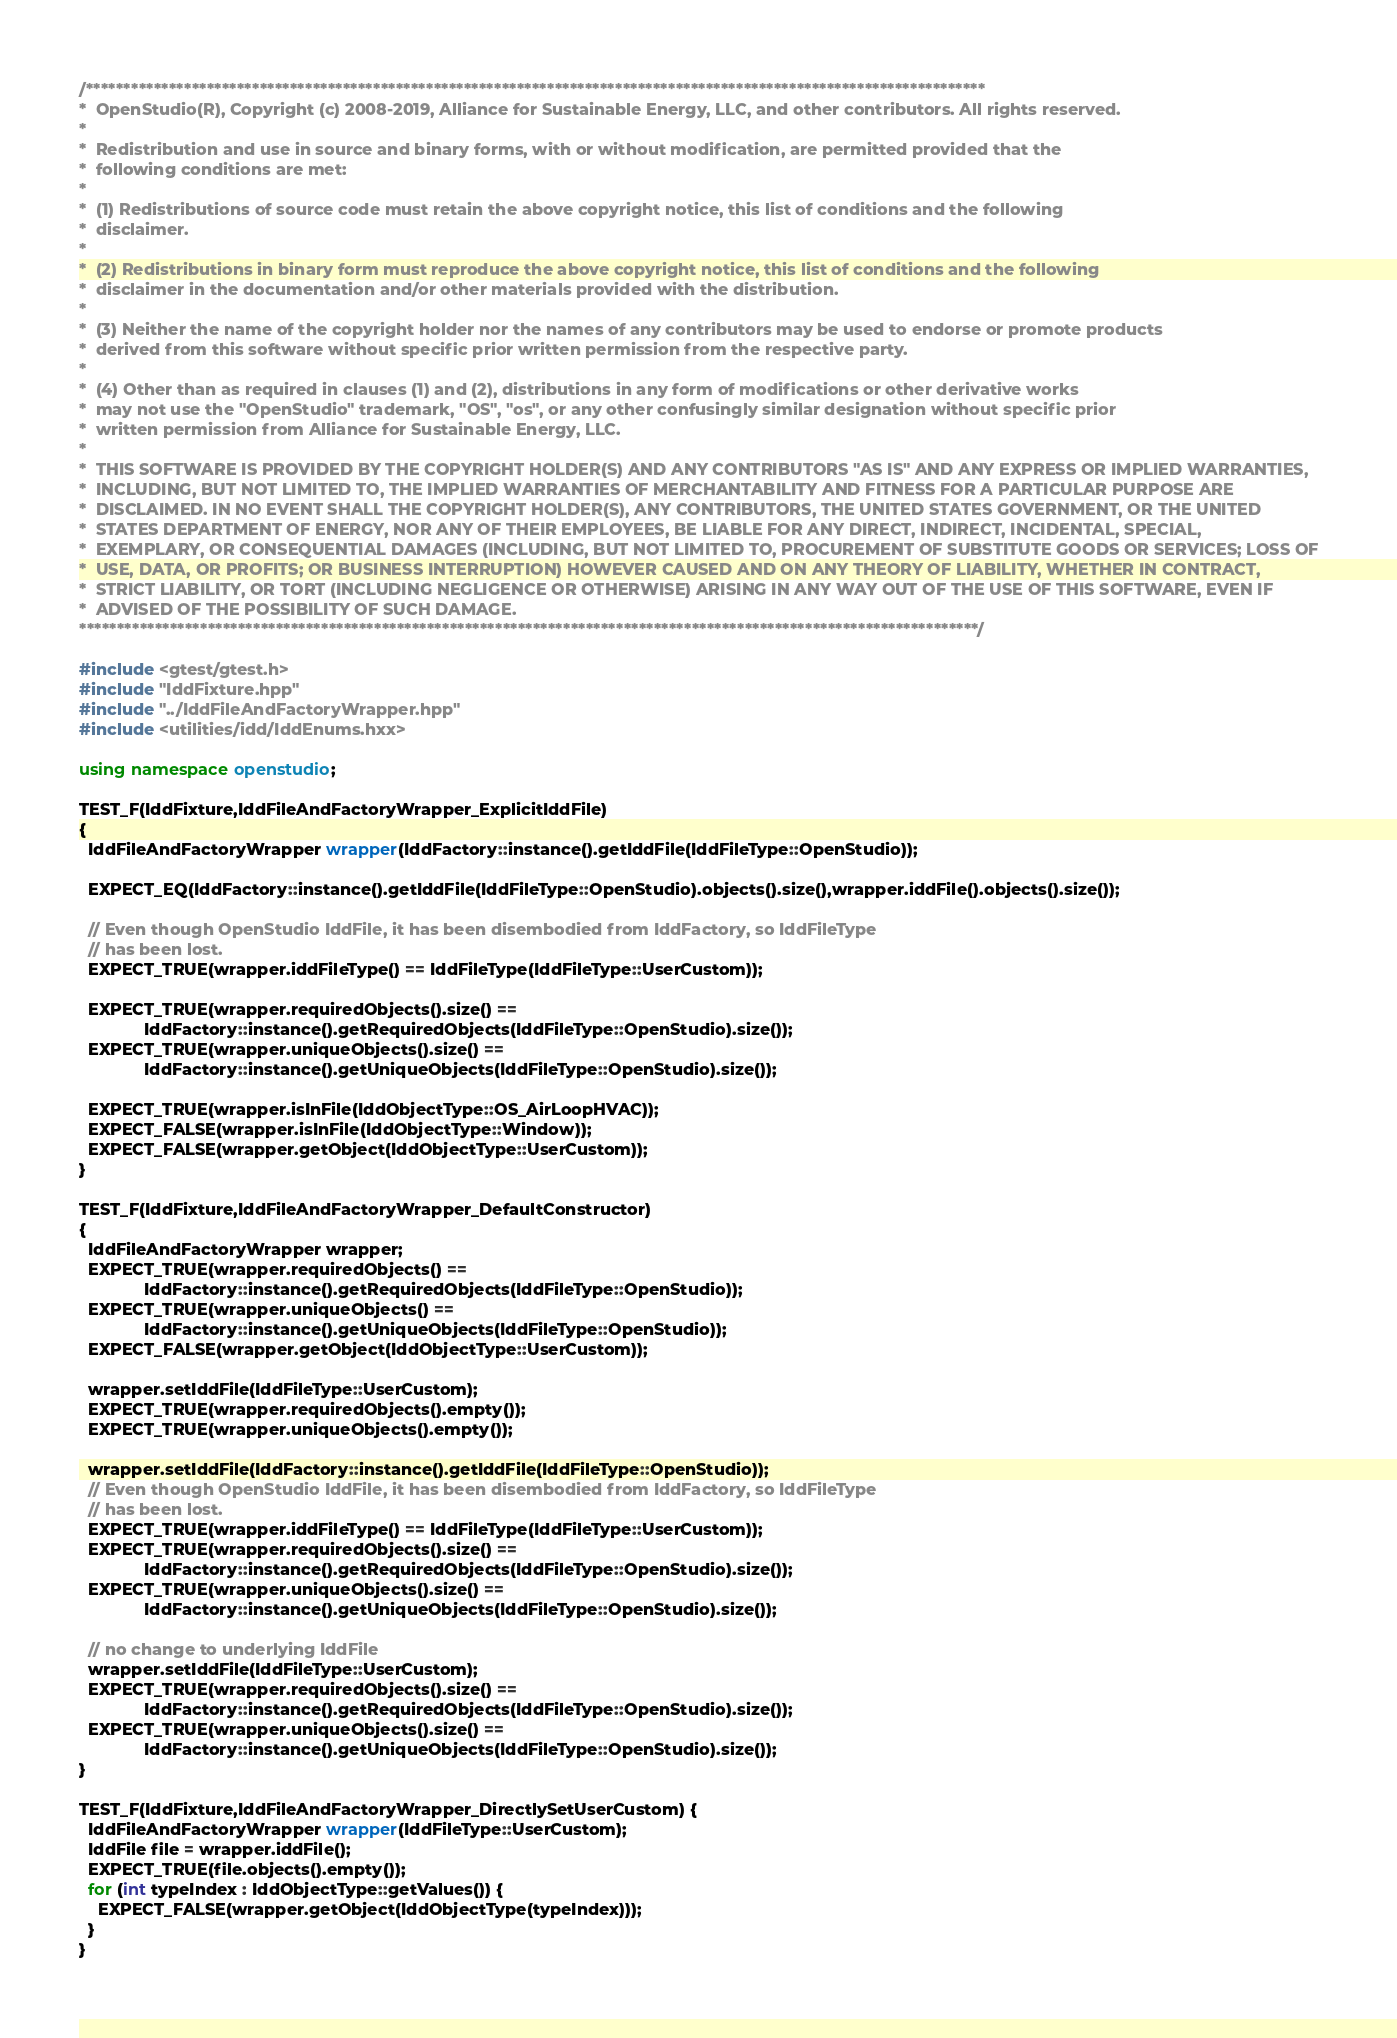<code> <loc_0><loc_0><loc_500><loc_500><_C++_>/***********************************************************************************************************************
*  OpenStudio(R), Copyright (c) 2008-2019, Alliance for Sustainable Energy, LLC, and other contributors. All rights reserved.
*
*  Redistribution and use in source and binary forms, with or without modification, are permitted provided that the
*  following conditions are met:
*
*  (1) Redistributions of source code must retain the above copyright notice, this list of conditions and the following
*  disclaimer.
*
*  (2) Redistributions in binary form must reproduce the above copyright notice, this list of conditions and the following
*  disclaimer in the documentation and/or other materials provided with the distribution.
*
*  (3) Neither the name of the copyright holder nor the names of any contributors may be used to endorse or promote products
*  derived from this software without specific prior written permission from the respective party.
*
*  (4) Other than as required in clauses (1) and (2), distributions in any form of modifications or other derivative works
*  may not use the "OpenStudio" trademark, "OS", "os", or any other confusingly similar designation without specific prior
*  written permission from Alliance for Sustainable Energy, LLC.
*
*  THIS SOFTWARE IS PROVIDED BY THE COPYRIGHT HOLDER(S) AND ANY CONTRIBUTORS "AS IS" AND ANY EXPRESS OR IMPLIED WARRANTIES,
*  INCLUDING, BUT NOT LIMITED TO, THE IMPLIED WARRANTIES OF MERCHANTABILITY AND FITNESS FOR A PARTICULAR PURPOSE ARE
*  DISCLAIMED. IN NO EVENT SHALL THE COPYRIGHT HOLDER(S), ANY CONTRIBUTORS, THE UNITED STATES GOVERNMENT, OR THE UNITED
*  STATES DEPARTMENT OF ENERGY, NOR ANY OF THEIR EMPLOYEES, BE LIABLE FOR ANY DIRECT, INDIRECT, INCIDENTAL, SPECIAL,
*  EXEMPLARY, OR CONSEQUENTIAL DAMAGES (INCLUDING, BUT NOT LIMITED TO, PROCUREMENT OF SUBSTITUTE GOODS OR SERVICES; LOSS OF
*  USE, DATA, OR PROFITS; OR BUSINESS INTERRUPTION) HOWEVER CAUSED AND ON ANY THEORY OF LIABILITY, WHETHER IN CONTRACT,
*  STRICT LIABILITY, OR TORT (INCLUDING NEGLIGENCE OR OTHERWISE) ARISING IN ANY WAY OUT OF THE USE OF THIS SOFTWARE, EVEN IF
*  ADVISED OF THE POSSIBILITY OF SUCH DAMAGE.
***********************************************************************************************************************/

#include <gtest/gtest.h>
#include "IddFixture.hpp"
#include "../IddFileAndFactoryWrapper.hpp"
#include <utilities/idd/IddEnums.hxx>

using namespace openstudio;

TEST_F(IddFixture,IddFileAndFactoryWrapper_ExplicitIddFile)
{
  IddFileAndFactoryWrapper wrapper(IddFactory::instance().getIddFile(IddFileType::OpenStudio));

  EXPECT_EQ(IddFactory::instance().getIddFile(IddFileType::OpenStudio).objects().size(),wrapper.iddFile().objects().size());

  // Even though OpenStudio IddFile, it has been disembodied from IddFactory, so IddFileType
  // has been lost.
  EXPECT_TRUE(wrapper.iddFileType() == IddFileType(IddFileType::UserCustom));

  EXPECT_TRUE(wrapper.requiredObjects().size() ==
              IddFactory::instance().getRequiredObjects(IddFileType::OpenStudio).size());
  EXPECT_TRUE(wrapper.uniqueObjects().size() ==
              IddFactory::instance().getUniqueObjects(IddFileType::OpenStudio).size());

  EXPECT_TRUE(wrapper.isInFile(IddObjectType::OS_AirLoopHVAC));
  EXPECT_FALSE(wrapper.isInFile(IddObjectType::Window));
  EXPECT_FALSE(wrapper.getObject(IddObjectType::UserCustom));
}

TEST_F(IddFixture,IddFileAndFactoryWrapper_DefaultConstructor)
{
  IddFileAndFactoryWrapper wrapper;
  EXPECT_TRUE(wrapper.requiredObjects() ==
              IddFactory::instance().getRequiredObjects(IddFileType::OpenStudio));
  EXPECT_TRUE(wrapper.uniqueObjects() ==
              IddFactory::instance().getUniqueObjects(IddFileType::OpenStudio));
  EXPECT_FALSE(wrapper.getObject(IddObjectType::UserCustom));

  wrapper.setIddFile(IddFileType::UserCustom);
  EXPECT_TRUE(wrapper.requiredObjects().empty());
  EXPECT_TRUE(wrapper.uniqueObjects().empty());

  wrapper.setIddFile(IddFactory::instance().getIddFile(IddFileType::OpenStudio));
  // Even though OpenStudio IddFile, it has been disembodied from IddFactory, so IddFileType
  // has been lost.
  EXPECT_TRUE(wrapper.iddFileType() == IddFileType(IddFileType::UserCustom));
  EXPECT_TRUE(wrapper.requiredObjects().size() ==
              IddFactory::instance().getRequiredObjects(IddFileType::OpenStudio).size());
  EXPECT_TRUE(wrapper.uniqueObjects().size() ==
              IddFactory::instance().getUniqueObjects(IddFileType::OpenStudio).size());

  // no change to underlying IddFile
  wrapper.setIddFile(IddFileType::UserCustom);
  EXPECT_TRUE(wrapper.requiredObjects().size() ==
              IddFactory::instance().getRequiredObjects(IddFileType::OpenStudio).size());
  EXPECT_TRUE(wrapper.uniqueObjects().size() ==
              IddFactory::instance().getUniqueObjects(IddFileType::OpenStudio).size());
}

TEST_F(IddFixture,IddFileAndFactoryWrapper_DirectlySetUserCustom) {
  IddFileAndFactoryWrapper wrapper(IddFileType::UserCustom);
  IddFile file = wrapper.iddFile();
  EXPECT_TRUE(file.objects().empty());
  for (int typeIndex : IddObjectType::getValues()) {
    EXPECT_FALSE(wrapper.getObject(IddObjectType(typeIndex)));
  }
}
</code> 